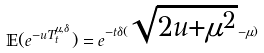<formula> <loc_0><loc_0><loc_500><loc_500>\mathbb { E } ( e ^ { - u T _ { t } ^ { \mu , \delta } } ) = e ^ { - t \delta ( \sqrt { 2 u + \mu ^ { 2 } } - \mu ) }</formula> 